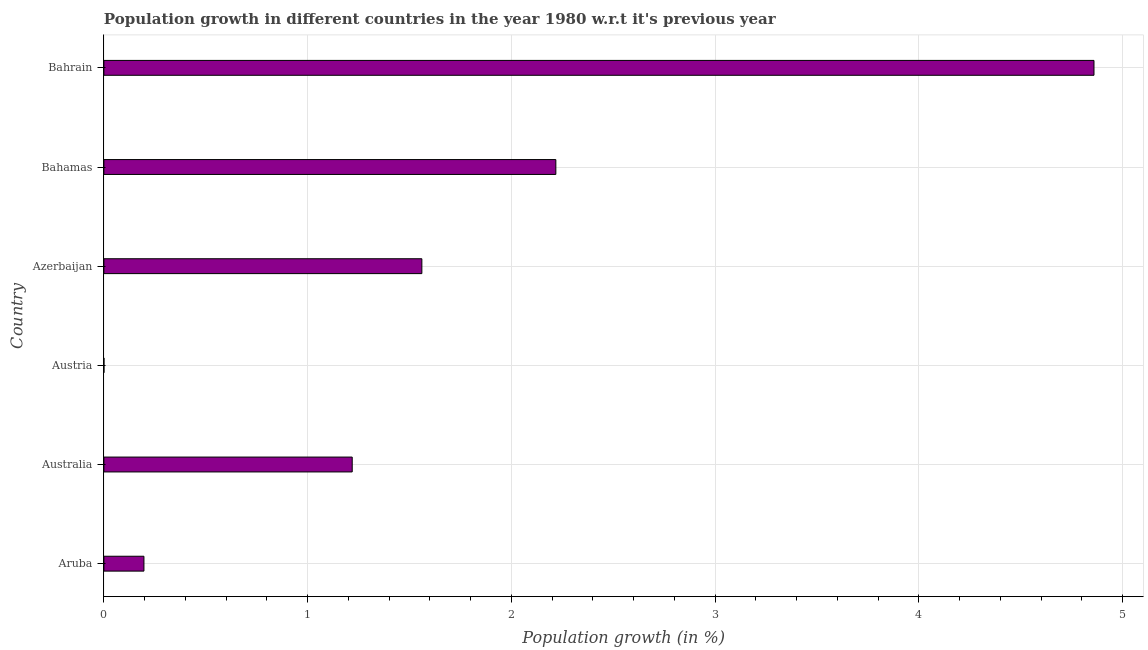Does the graph contain any zero values?
Your response must be concise. No. What is the title of the graph?
Keep it short and to the point. Population growth in different countries in the year 1980 w.r.t it's previous year. What is the label or title of the X-axis?
Your response must be concise. Population growth (in %). What is the label or title of the Y-axis?
Provide a short and direct response. Country. What is the population growth in Aruba?
Make the answer very short. 0.2. Across all countries, what is the maximum population growth?
Provide a succinct answer. 4.86. Across all countries, what is the minimum population growth?
Keep it short and to the point. 0. In which country was the population growth maximum?
Keep it short and to the point. Bahrain. In which country was the population growth minimum?
Keep it short and to the point. Austria. What is the sum of the population growth?
Your answer should be compact. 10.05. What is the difference between the population growth in Azerbaijan and Bahamas?
Keep it short and to the point. -0.66. What is the average population growth per country?
Your response must be concise. 1.68. What is the median population growth?
Provide a short and direct response. 1.39. Is the population growth in Australia less than that in Bahrain?
Provide a short and direct response. Yes. What is the difference between the highest and the second highest population growth?
Keep it short and to the point. 2.64. What is the difference between the highest and the lowest population growth?
Your answer should be compact. 4.86. How many bars are there?
Provide a succinct answer. 6. Are all the bars in the graph horizontal?
Provide a short and direct response. Yes. How many countries are there in the graph?
Offer a terse response. 6. What is the Population growth (in %) of Aruba?
Keep it short and to the point. 0.2. What is the Population growth (in %) in Australia?
Keep it short and to the point. 1.22. What is the Population growth (in %) in Austria?
Make the answer very short. 0. What is the Population growth (in %) of Azerbaijan?
Make the answer very short. 1.56. What is the Population growth (in %) in Bahamas?
Your response must be concise. 2.22. What is the Population growth (in %) in Bahrain?
Provide a short and direct response. 4.86. What is the difference between the Population growth (in %) in Aruba and Australia?
Provide a succinct answer. -1.02. What is the difference between the Population growth (in %) in Aruba and Austria?
Your answer should be compact. 0.2. What is the difference between the Population growth (in %) in Aruba and Azerbaijan?
Offer a terse response. -1.36. What is the difference between the Population growth (in %) in Aruba and Bahamas?
Your response must be concise. -2.02. What is the difference between the Population growth (in %) in Aruba and Bahrain?
Your response must be concise. -4.66. What is the difference between the Population growth (in %) in Australia and Austria?
Your answer should be compact. 1.22. What is the difference between the Population growth (in %) in Australia and Azerbaijan?
Offer a very short reply. -0.34. What is the difference between the Population growth (in %) in Australia and Bahamas?
Provide a succinct answer. -1. What is the difference between the Population growth (in %) in Australia and Bahrain?
Provide a short and direct response. -3.64. What is the difference between the Population growth (in %) in Austria and Azerbaijan?
Give a very brief answer. -1.56. What is the difference between the Population growth (in %) in Austria and Bahamas?
Provide a short and direct response. -2.22. What is the difference between the Population growth (in %) in Austria and Bahrain?
Make the answer very short. -4.86. What is the difference between the Population growth (in %) in Azerbaijan and Bahamas?
Your response must be concise. -0.66. What is the difference between the Population growth (in %) in Azerbaijan and Bahrain?
Provide a short and direct response. -3.3. What is the difference between the Population growth (in %) in Bahamas and Bahrain?
Ensure brevity in your answer.  -2.64. What is the ratio of the Population growth (in %) in Aruba to that in Australia?
Ensure brevity in your answer.  0.16. What is the ratio of the Population growth (in %) in Aruba to that in Austria?
Offer a very short reply. 1854.76. What is the ratio of the Population growth (in %) in Aruba to that in Azerbaijan?
Your response must be concise. 0.13. What is the ratio of the Population growth (in %) in Aruba to that in Bahamas?
Give a very brief answer. 0.09. What is the ratio of the Population growth (in %) in Australia to that in Austria?
Make the answer very short. 1.15e+04. What is the ratio of the Population growth (in %) in Australia to that in Azerbaijan?
Ensure brevity in your answer.  0.78. What is the ratio of the Population growth (in %) in Australia to that in Bahamas?
Your response must be concise. 0.55. What is the ratio of the Population growth (in %) in Australia to that in Bahrain?
Your answer should be very brief. 0.25. What is the ratio of the Population growth (in %) in Austria to that in Bahamas?
Your response must be concise. 0. What is the ratio of the Population growth (in %) in Azerbaijan to that in Bahamas?
Offer a very short reply. 0.7. What is the ratio of the Population growth (in %) in Azerbaijan to that in Bahrain?
Your answer should be very brief. 0.32. What is the ratio of the Population growth (in %) in Bahamas to that in Bahrain?
Your answer should be very brief. 0.46. 